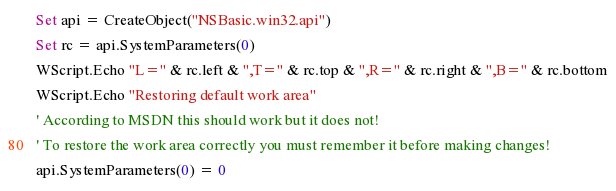<code> <loc_0><loc_0><loc_500><loc_500><_VisualBasic_>Set api = CreateObject("NSBasic.win32.api")
Set rc = api.SystemParameters(0)
WScript.Echo "L=" & rc.left & ",T=" & rc.top & ",R=" & rc.right & ",B=" & rc.bottom
WScript.Echo "Restoring default work area"
' According to MSDN this should work but it does not!
' To restore the work area correctly you must remember it before making changes!
api.SystemParameters(0) = 0</code> 